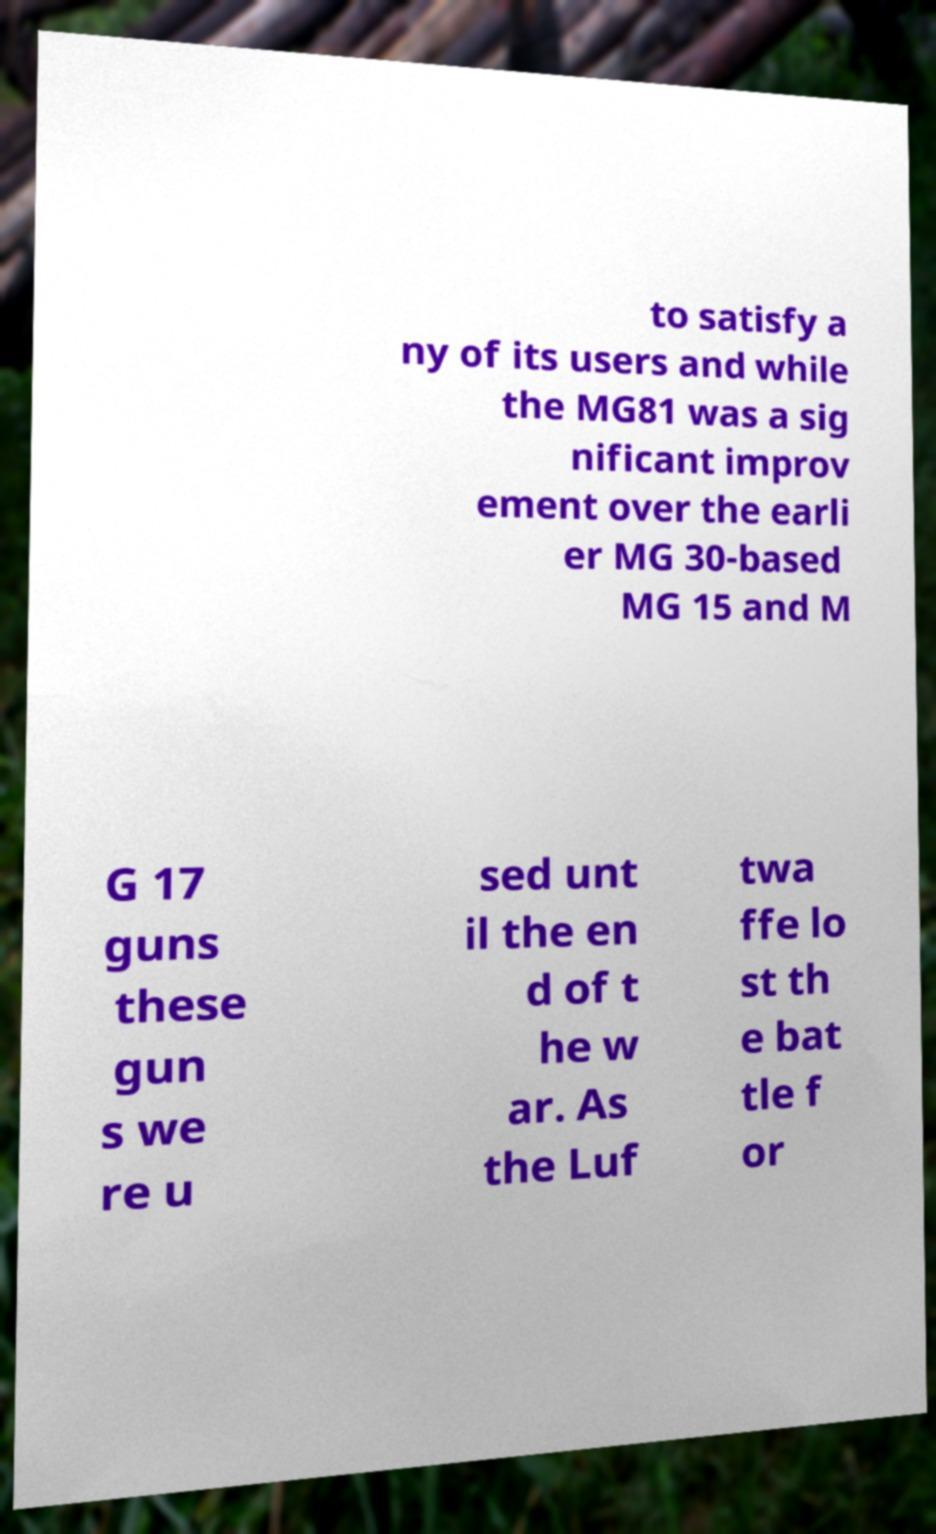There's text embedded in this image that I need extracted. Can you transcribe it verbatim? to satisfy a ny of its users and while the MG81 was a sig nificant improv ement over the earli er MG 30-based MG 15 and M G 17 guns these gun s we re u sed unt il the en d of t he w ar. As the Luf twa ffe lo st th e bat tle f or 